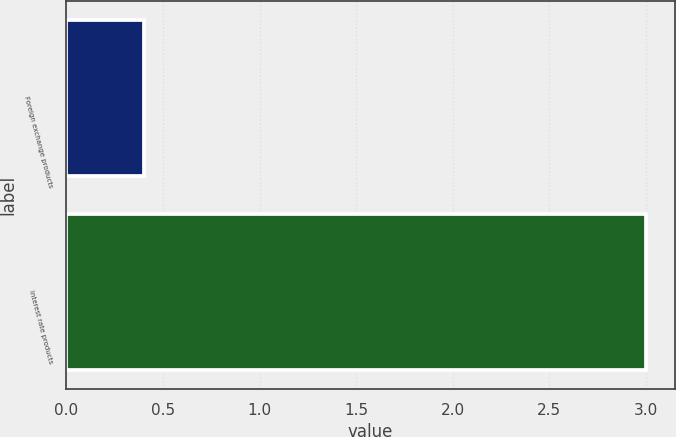Convert chart. <chart><loc_0><loc_0><loc_500><loc_500><bar_chart><fcel>Foreign exchange products<fcel>Interest rate products<nl><fcel>0.4<fcel>3<nl></chart> 